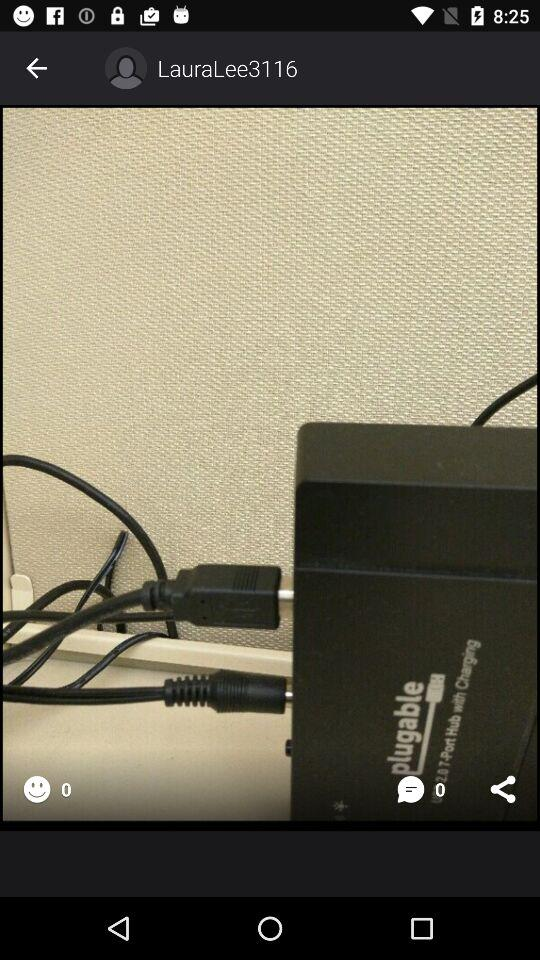What is the given username? The username is "LauraLee3116". 